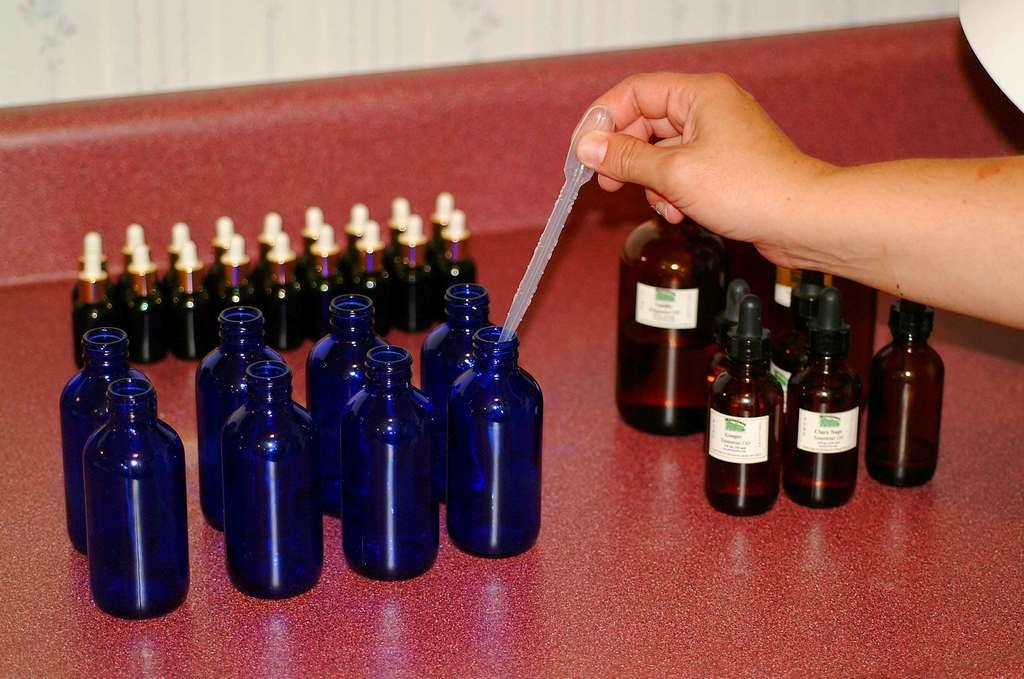What type of objects are on the left side of the image? There are medicinal bottles on the left side of the image. Are there any similar objects on the right side of the image? Yes, there are also medicinal bottles on the right side of the image. Where are the bottles located in the image? The bottles are placed on a table. What type of meat is hanging from the branch in the image? There is no meat or branch present in the image; it only features medicinal bottles on a table. 